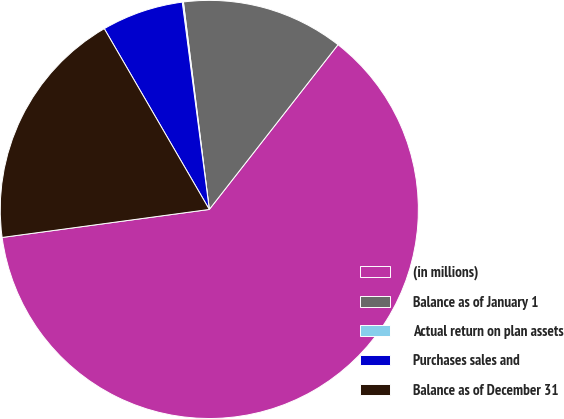<chart> <loc_0><loc_0><loc_500><loc_500><pie_chart><fcel>(in millions)<fcel>Balance as of January 1<fcel>Actual return on plan assets<fcel>Purchases sales and<fcel>Balance as of December 31<nl><fcel>62.3%<fcel>12.53%<fcel>0.09%<fcel>6.31%<fcel>18.76%<nl></chart> 